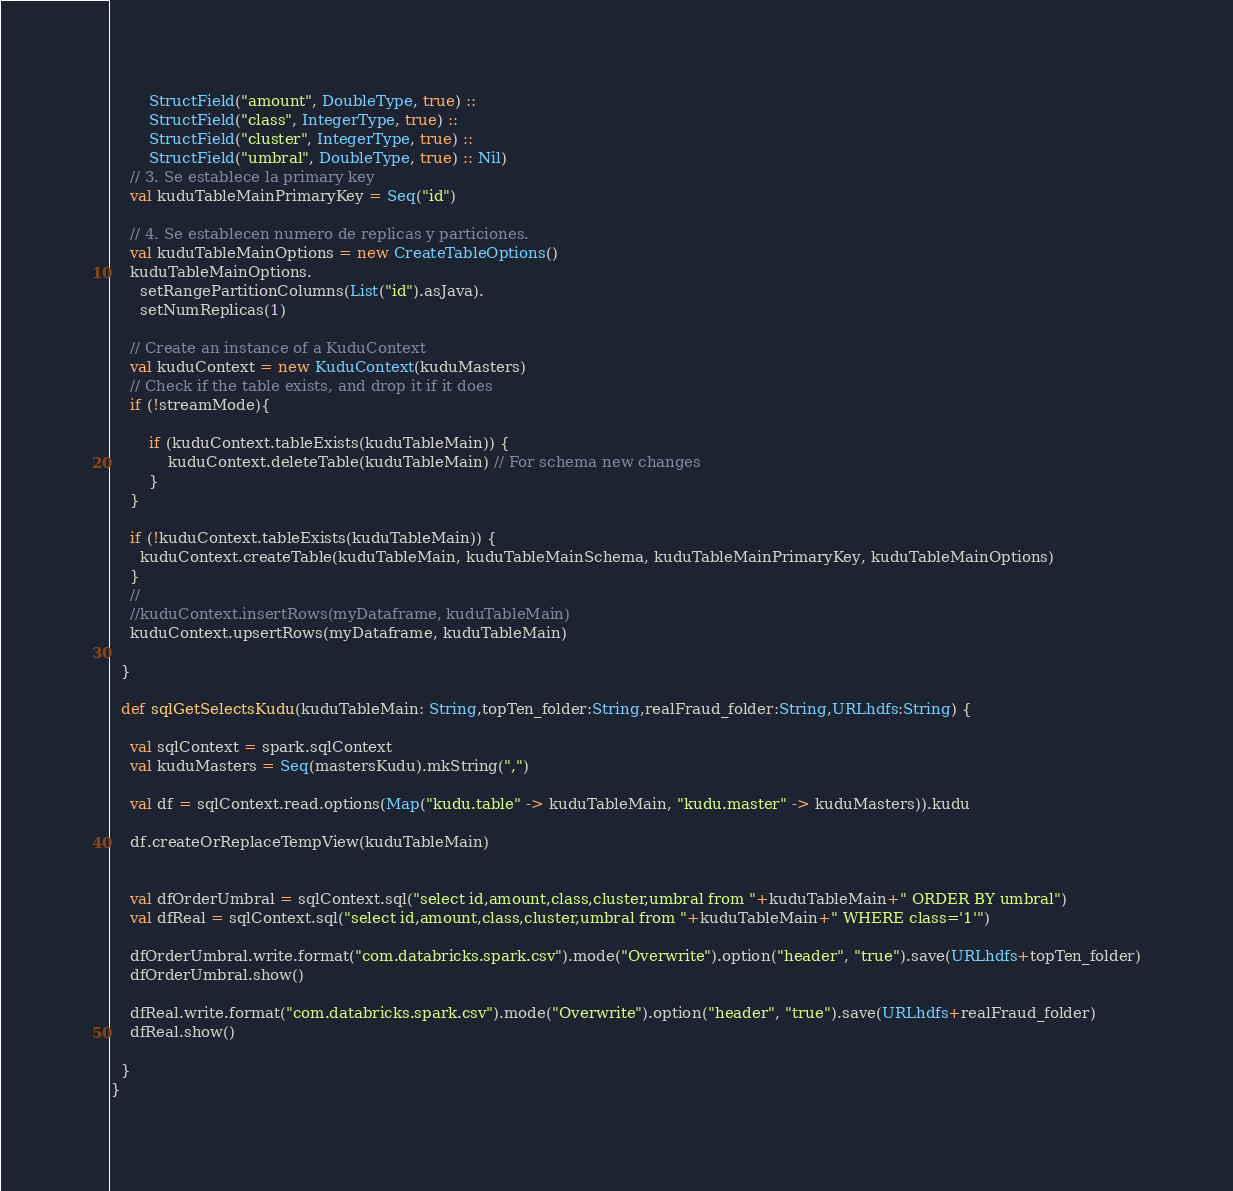<code> <loc_0><loc_0><loc_500><loc_500><_Scala_>        StructField("amount", DoubleType, true) ::
        StructField("class", IntegerType, true) ::
        StructField("cluster", IntegerType, true) ::
        StructField("umbral", DoubleType, true) :: Nil)
    // 3. Se establece la primary key
    val kuduTableMainPrimaryKey = Seq("id")

    // 4. Se establecen numero de replicas y particiones.
    val kuduTableMainOptions = new CreateTableOptions()
    kuduTableMainOptions.
      setRangePartitionColumns(List("id").asJava).
      setNumReplicas(1)

    // Create an instance of a KuduContext
    val kuduContext = new KuduContext(kuduMasters)
    // Check if the table exists, and drop it if it does
    if (!streamMode){
      
        if (kuduContext.tableExists(kuduTableMain)) {
            kuduContext.deleteTable(kuduTableMain) // For schema new changes
        }
    }

    if (!kuduContext.tableExists(kuduTableMain)) {
      kuduContext.createTable(kuduTableMain, kuduTableMainSchema, kuduTableMainPrimaryKey, kuduTableMainOptions)
    }
    //    
    //kuduContext.insertRows(myDataframe, kuduTableMain)
    kuduContext.upsertRows(myDataframe, kuduTableMain)

  }

  def sqlGetSelectsKudu(kuduTableMain: String,topTen_folder:String,realFraud_folder:String,URLhdfs:String) {

    val sqlContext = spark.sqlContext
    val kuduMasters = Seq(mastersKudu).mkString(",")

    val df = sqlContext.read.options(Map("kudu.table" -> kuduTableMain, "kudu.master" -> kuduMasters)).kudu

    df.createOrReplaceTempView(kuduTableMain)
    
    
    val dfOrderUmbral = sqlContext.sql("select id,amount,class,cluster,umbral from "+kuduTableMain+" ORDER BY umbral")
    val dfReal = sqlContext.sql("select id,amount,class,cluster,umbral from "+kuduTableMain+" WHERE class='1'")

    dfOrderUmbral.write.format("com.databricks.spark.csv").mode("Overwrite").option("header", "true").save(URLhdfs+topTen_folder)
    dfOrderUmbral.show()
    
    dfReal.write.format("com.databricks.spark.csv").mode("Overwrite").option("header", "true").save(URLhdfs+realFraud_folder)
    dfReal.show()
    
  }
}
</code> 